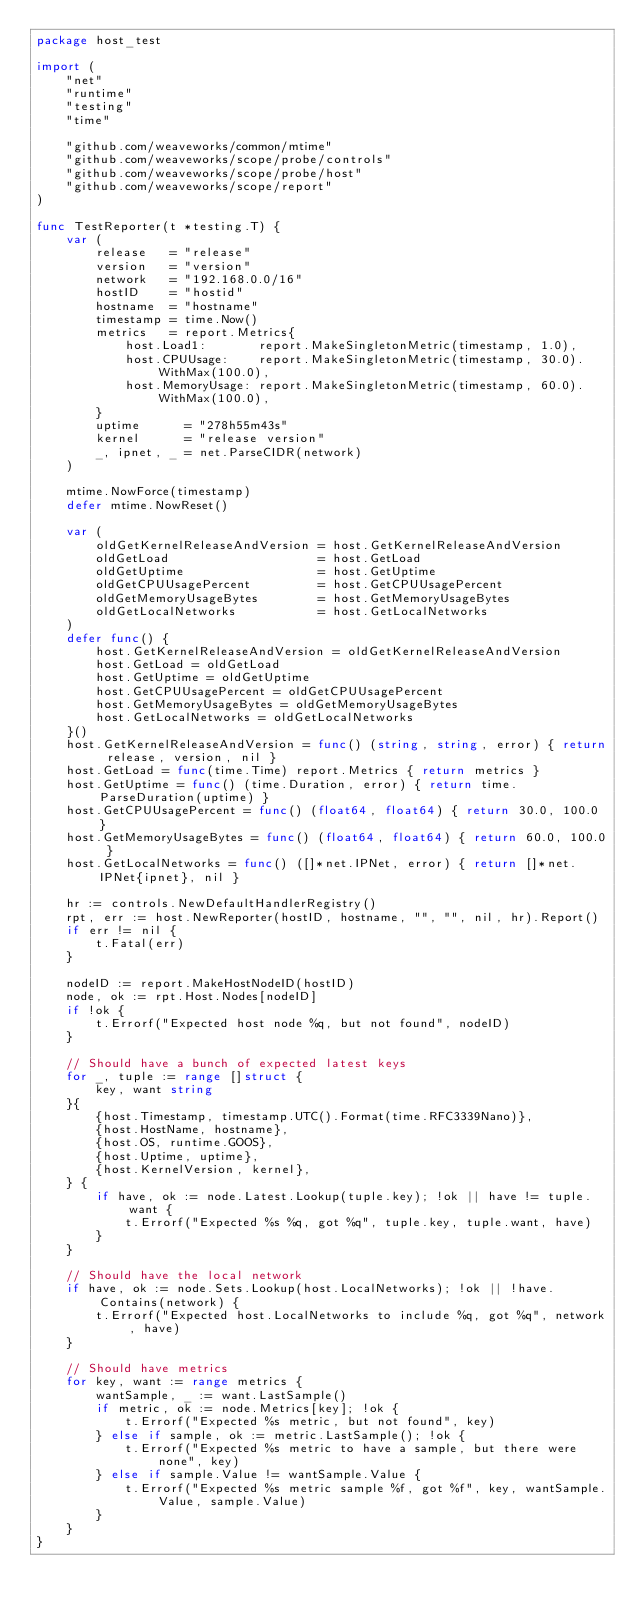Convert code to text. <code><loc_0><loc_0><loc_500><loc_500><_Go_>package host_test

import (
	"net"
	"runtime"
	"testing"
	"time"

	"github.com/weaveworks/common/mtime"
	"github.com/weaveworks/scope/probe/controls"
	"github.com/weaveworks/scope/probe/host"
	"github.com/weaveworks/scope/report"
)

func TestReporter(t *testing.T) {
	var (
		release   = "release"
		version   = "version"
		network   = "192.168.0.0/16"
		hostID    = "hostid"
		hostname  = "hostname"
		timestamp = time.Now()
		metrics   = report.Metrics{
			host.Load1:       report.MakeSingletonMetric(timestamp, 1.0),
			host.CPUUsage:    report.MakeSingletonMetric(timestamp, 30.0).WithMax(100.0),
			host.MemoryUsage: report.MakeSingletonMetric(timestamp, 60.0).WithMax(100.0),
		}
		uptime      = "278h55m43s"
		kernel      = "release version"
		_, ipnet, _ = net.ParseCIDR(network)
	)

	mtime.NowForce(timestamp)
	defer mtime.NowReset()

	var (
		oldGetKernelReleaseAndVersion = host.GetKernelReleaseAndVersion
		oldGetLoad                    = host.GetLoad
		oldGetUptime                  = host.GetUptime
		oldGetCPUUsagePercent         = host.GetCPUUsagePercent
		oldGetMemoryUsageBytes        = host.GetMemoryUsageBytes
		oldGetLocalNetworks           = host.GetLocalNetworks
	)
	defer func() {
		host.GetKernelReleaseAndVersion = oldGetKernelReleaseAndVersion
		host.GetLoad = oldGetLoad
		host.GetUptime = oldGetUptime
		host.GetCPUUsagePercent = oldGetCPUUsagePercent
		host.GetMemoryUsageBytes = oldGetMemoryUsageBytes
		host.GetLocalNetworks = oldGetLocalNetworks
	}()
	host.GetKernelReleaseAndVersion = func() (string, string, error) { return release, version, nil }
	host.GetLoad = func(time.Time) report.Metrics { return metrics }
	host.GetUptime = func() (time.Duration, error) { return time.ParseDuration(uptime) }
	host.GetCPUUsagePercent = func() (float64, float64) { return 30.0, 100.0 }
	host.GetMemoryUsageBytes = func() (float64, float64) { return 60.0, 100.0 }
	host.GetLocalNetworks = func() ([]*net.IPNet, error) { return []*net.IPNet{ipnet}, nil }

	hr := controls.NewDefaultHandlerRegistry()
	rpt, err := host.NewReporter(hostID, hostname, "", "", nil, hr).Report()
	if err != nil {
		t.Fatal(err)
	}

	nodeID := report.MakeHostNodeID(hostID)
	node, ok := rpt.Host.Nodes[nodeID]
	if !ok {
		t.Errorf("Expected host node %q, but not found", nodeID)
	}

	// Should have a bunch of expected latest keys
	for _, tuple := range []struct {
		key, want string
	}{
		{host.Timestamp, timestamp.UTC().Format(time.RFC3339Nano)},
		{host.HostName, hostname},
		{host.OS, runtime.GOOS},
		{host.Uptime, uptime},
		{host.KernelVersion, kernel},
	} {
		if have, ok := node.Latest.Lookup(tuple.key); !ok || have != tuple.want {
			t.Errorf("Expected %s %q, got %q", tuple.key, tuple.want, have)
		}
	}

	// Should have the local network
	if have, ok := node.Sets.Lookup(host.LocalNetworks); !ok || !have.Contains(network) {
		t.Errorf("Expected host.LocalNetworks to include %q, got %q", network, have)
	}

	// Should have metrics
	for key, want := range metrics {
		wantSample, _ := want.LastSample()
		if metric, ok := node.Metrics[key]; !ok {
			t.Errorf("Expected %s metric, but not found", key)
		} else if sample, ok := metric.LastSample(); !ok {
			t.Errorf("Expected %s metric to have a sample, but there were none", key)
		} else if sample.Value != wantSample.Value {
			t.Errorf("Expected %s metric sample %f, got %f", key, wantSample.Value, sample.Value)
		}
	}
}
</code> 